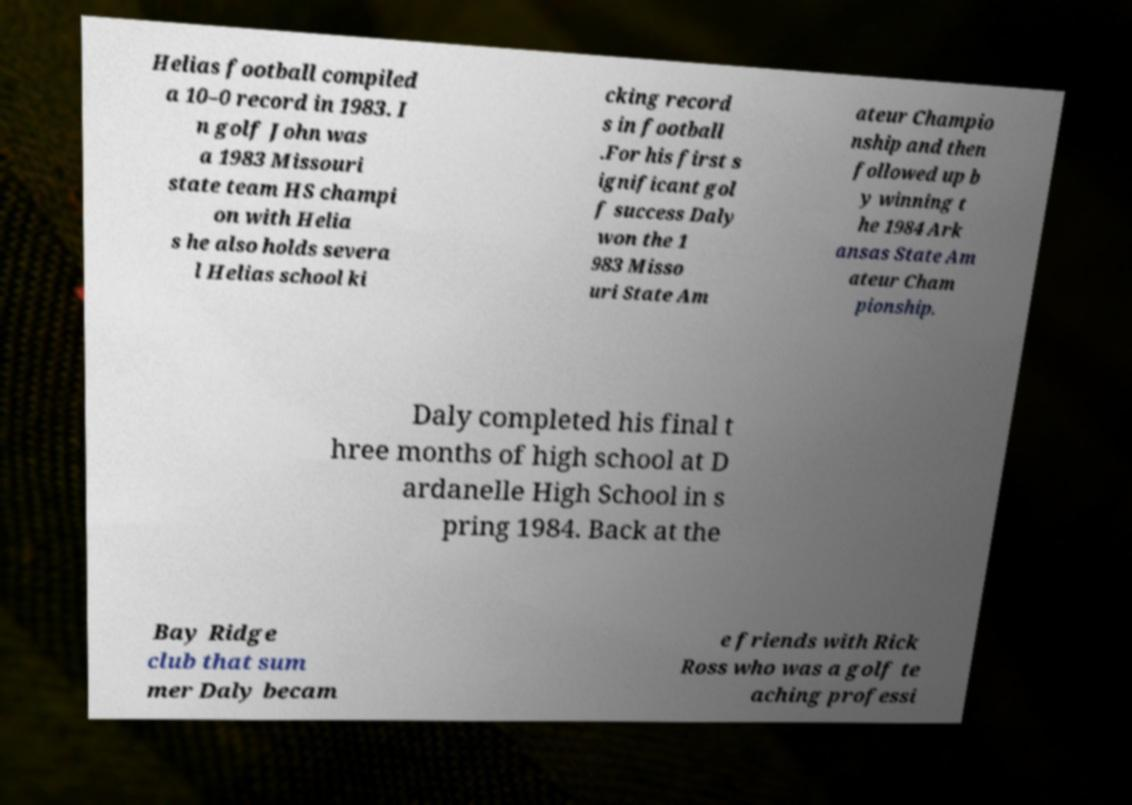Can you accurately transcribe the text from the provided image for me? Helias football compiled a 10–0 record in 1983. I n golf John was a 1983 Missouri state team HS champi on with Helia s he also holds severa l Helias school ki cking record s in football .For his first s ignificant gol f success Daly won the 1 983 Misso uri State Am ateur Champio nship and then followed up b y winning t he 1984 Ark ansas State Am ateur Cham pionship. Daly completed his final t hree months of high school at D ardanelle High School in s pring 1984. Back at the Bay Ridge club that sum mer Daly becam e friends with Rick Ross who was a golf te aching professi 